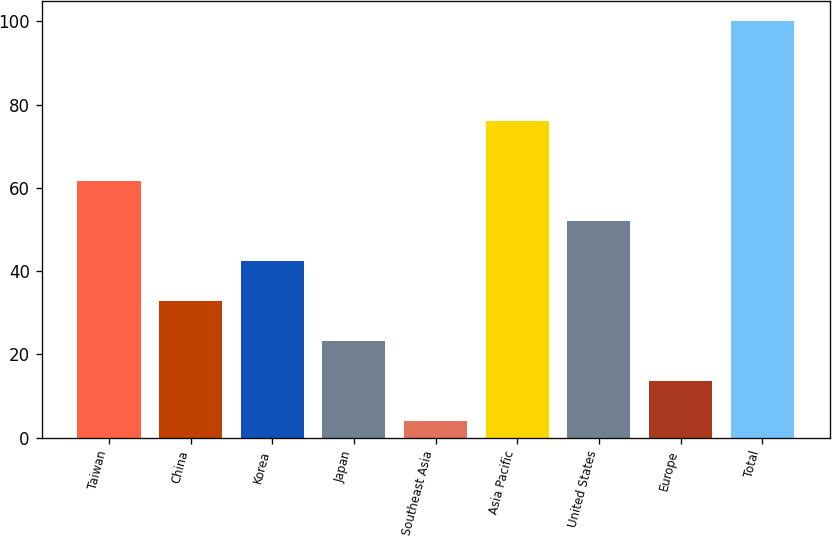Convert chart. <chart><loc_0><loc_0><loc_500><loc_500><bar_chart><fcel>Taiwan<fcel>China<fcel>Korea<fcel>Japan<fcel>Southeast Asia<fcel>Asia Pacific<fcel>United States<fcel>Europe<fcel>Total<nl><fcel>61.6<fcel>32.8<fcel>42.4<fcel>23.2<fcel>4<fcel>76<fcel>52<fcel>13.6<fcel>100<nl></chart> 